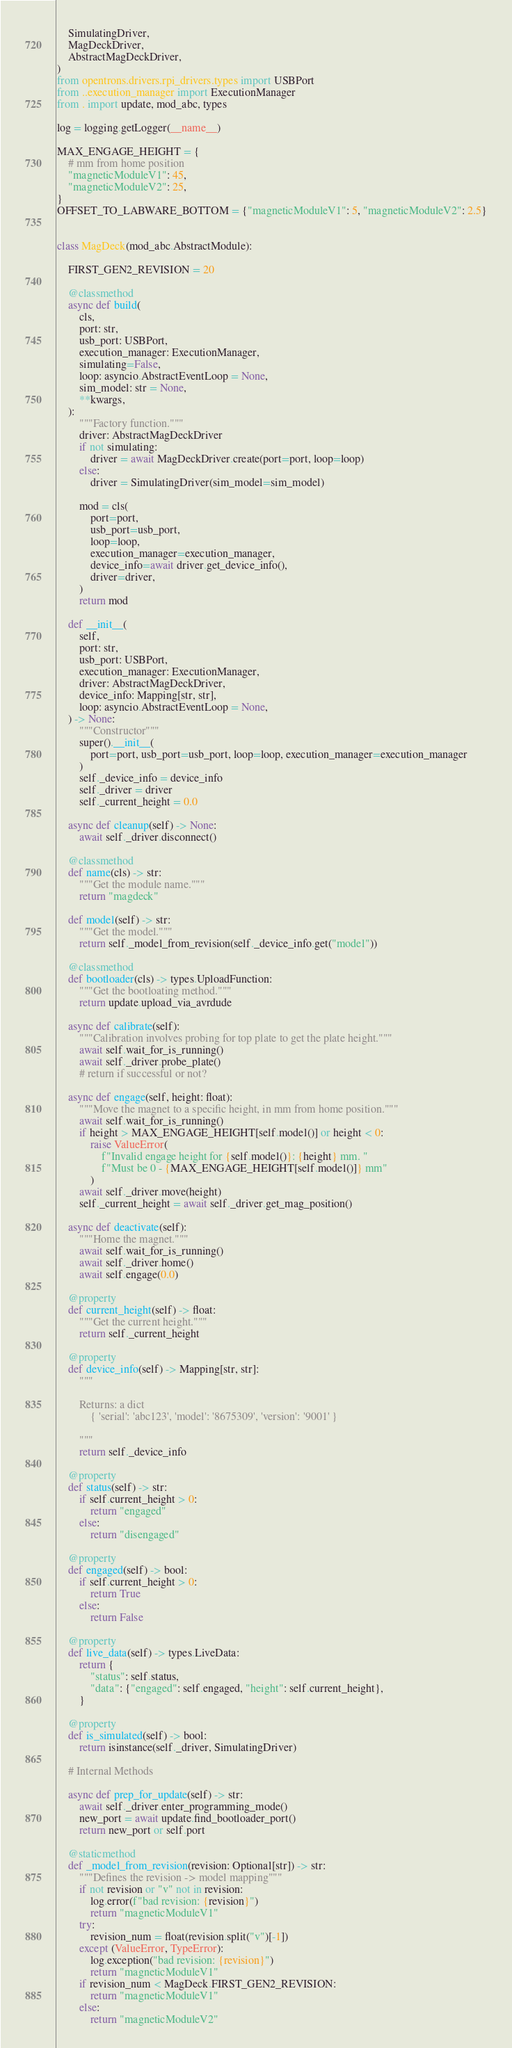<code> <loc_0><loc_0><loc_500><loc_500><_Python_>    SimulatingDriver,
    MagDeckDriver,
    AbstractMagDeckDriver,
)
from opentrons.drivers.rpi_drivers.types import USBPort
from ..execution_manager import ExecutionManager
from . import update, mod_abc, types

log = logging.getLogger(__name__)

MAX_ENGAGE_HEIGHT = {
    # mm from home position
    "magneticModuleV1": 45,
    "magneticModuleV2": 25,
}
OFFSET_TO_LABWARE_BOTTOM = {"magneticModuleV1": 5, "magneticModuleV2": 2.5}


class MagDeck(mod_abc.AbstractModule):

    FIRST_GEN2_REVISION = 20

    @classmethod
    async def build(
        cls,
        port: str,
        usb_port: USBPort,
        execution_manager: ExecutionManager,
        simulating=False,
        loop: asyncio.AbstractEventLoop = None,
        sim_model: str = None,
        **kwargs,
    ):
        """Factory function."""
        driver: AbstractMagDeckDriver
        if not simulating:
            driver = await MagDeckDriver.create(port=port, loop=loop)
        else:
            driver = SimulatingDriver(sim_model=sim_model)

        mod = cls(
            port=port,
            usb_port=usb_port,
            loop=loop,
            execution_manager=execution_manager,
            device_info=await driver.get_device_info(),
            driver=driver,
        )
        return mod

    def __init__(
        self,
        port: str,
        usb_port: USBPort,
        execution_manager: ExecutionManager,
        driver: AbstractMagDeckDriver,
        device_info: Mapping[str, str],
        loop: asyncio.AbstractEventLoop = None,
    ) -> None:
        """Constructor"""
        super().__init__(
            port=port, usb_port=usb_port, loop=loop, execution_manager=execution_manager
        )
        self._device_info = device_info
        self._driver = driver
        self._current_height = 0.0

    async def cleanup(self) -> None:
        await self._driver.disconnect()

    @classmethod
    def name(cls) -> str:
        """Get the module name."""
        return "magdeck"

    def model(self) -> str:
        """Get the model."""
        return self._model_from_revision(self._device_info.get("model"))

    @classmethod
    def bootloader(cls) -> types.UploadFunction:
        """Get the bootloating method."""
        return update.upload_via_avrdude

    async def calibrate(self):
        """Calibration involves probing for top plate to get the plate height."""
        await self.wait_for_is_running()
        await self._driver.probe_plate()
        # return if successful or not?

    async def engage(self, height: float):
        """Move the magnet to a specific height, in mm from home position."""
        await self.wait_for_is_running()
        if height > MAX_ENGAGE_HEIGHT[self.model()] or height < 0:
            raise ValueError(
                f"Invalid engage height for {self.model()}: {height} mm. "
                f"Must be 0 - {MAX_ENGAGE_HEIGHT[self.model()]} mm"
            )
        await self._driver.move(height)
        self._current_height = await self._driver.get_mag_position()

    async def deactivate(self):
        """Home the magnet."""
        await self.wait_for_is_running()
        await self._driver.home()
        await self.engage(0.0)

    @property
    def current_height(self) -> float:
        """Get the current height."""
        return self._current_height

    @property
    def device_info(self) -> Mapping[str, str]:
        """

        Returns: a dict
            { 'serial': 'abc123', 'model': '8675309', 'version': '9001' }

        """
        return self._device_info

    @property
    def status(self) -> str:
        if self.current_height > 0:
            return "engaged"
        else:
            return "disengaged"

    @property
    def engaged(self) -> bool:
        if self.current_height > 0:
            return True
        else:
            return False

    @property
    def live_data(self) -> types.LiveData:
        return {
            "status": self.status,
            "data": {"engaged": self.engaged, "height": self.current_height},
        }

    @property
    def is_simulated(self) -> bool:
        return isinstance(self._driver, SimulatingDriver)

    # Internal Methods

    async def prep_for_update(self) -> str:
        await self._driver.enter_programming_mode()
        new_port = await update.find_bootloader_port()
        return new_port or self.port

    @staticmethod
    def _model_from_revision(revision: Optional[str]) -> str:
        """Defines the revision -> model mapping"""
        if not revision or "v" not in revision:
            log.error(f"bad revision: {revision}")
            return "magneticModuleV1"
        try:
            revision_num = float(revision.split("v")[-1])
        except (ValueError, TypeError):
            log.exception("bad revision: {revision}")
            return "magneticModuleV1"
        if revision_num < MagDeck.FIRST_GEN2_REVISION:
            return "magneticModuleV1"
        else:
            return "magneticModuleV2"
</code> 